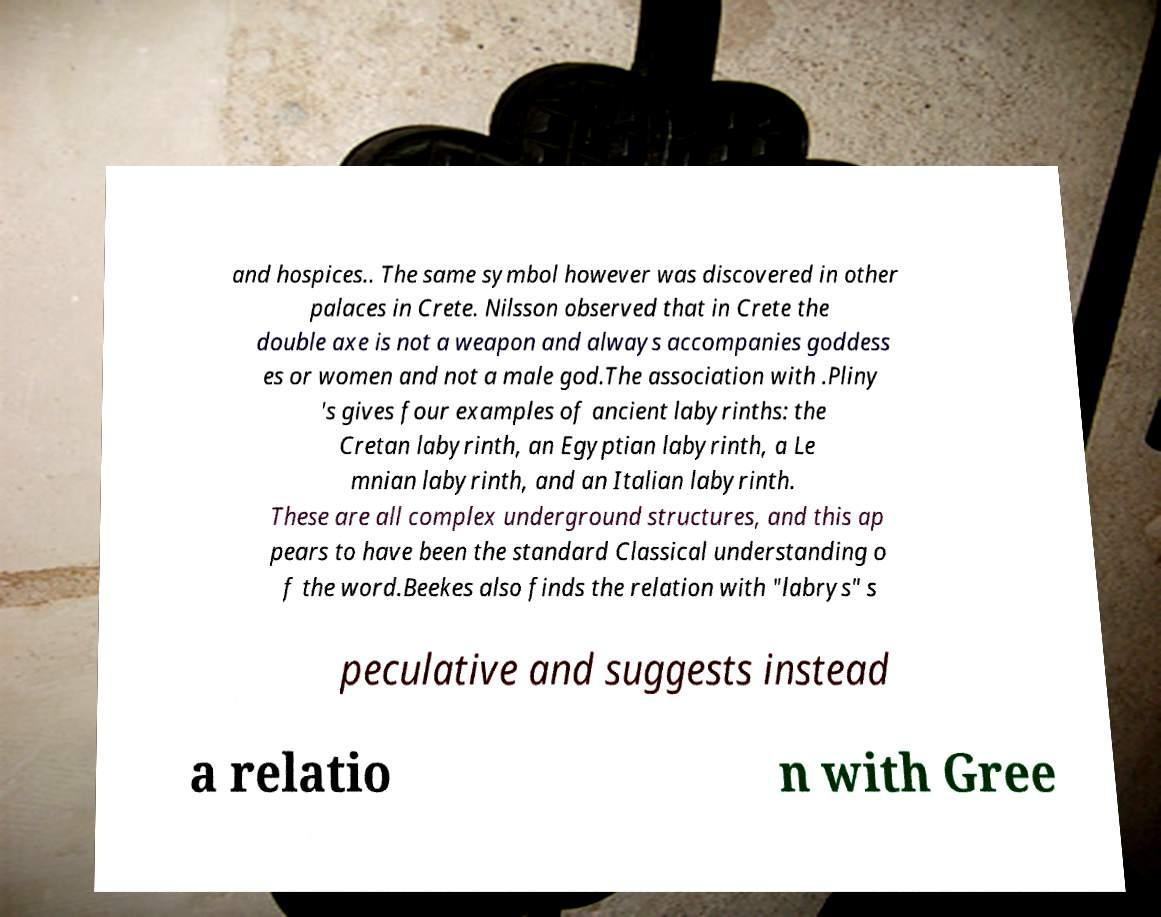Please read and relay the text visible in this image. What does it say? and hospices.. The same symbol however was discovered in other palaces in Crete. Nilsson observed that in Crete the double axe is not a weapon and always accompanies goddess es or women and not a male god.The association with .Pliny 's gives four examples of ancient labyrinths: the Cretan labyrinth, an Egyptian labyrinth, a Le mnian labyrinth, and an Italian labyrinth. These are all complex underground structures, and this ap pears to have been the standard Classical understanding o f the word.Beekes also finds the relation with "labrys" s peculative and suggests instead a relatio n with Gree 